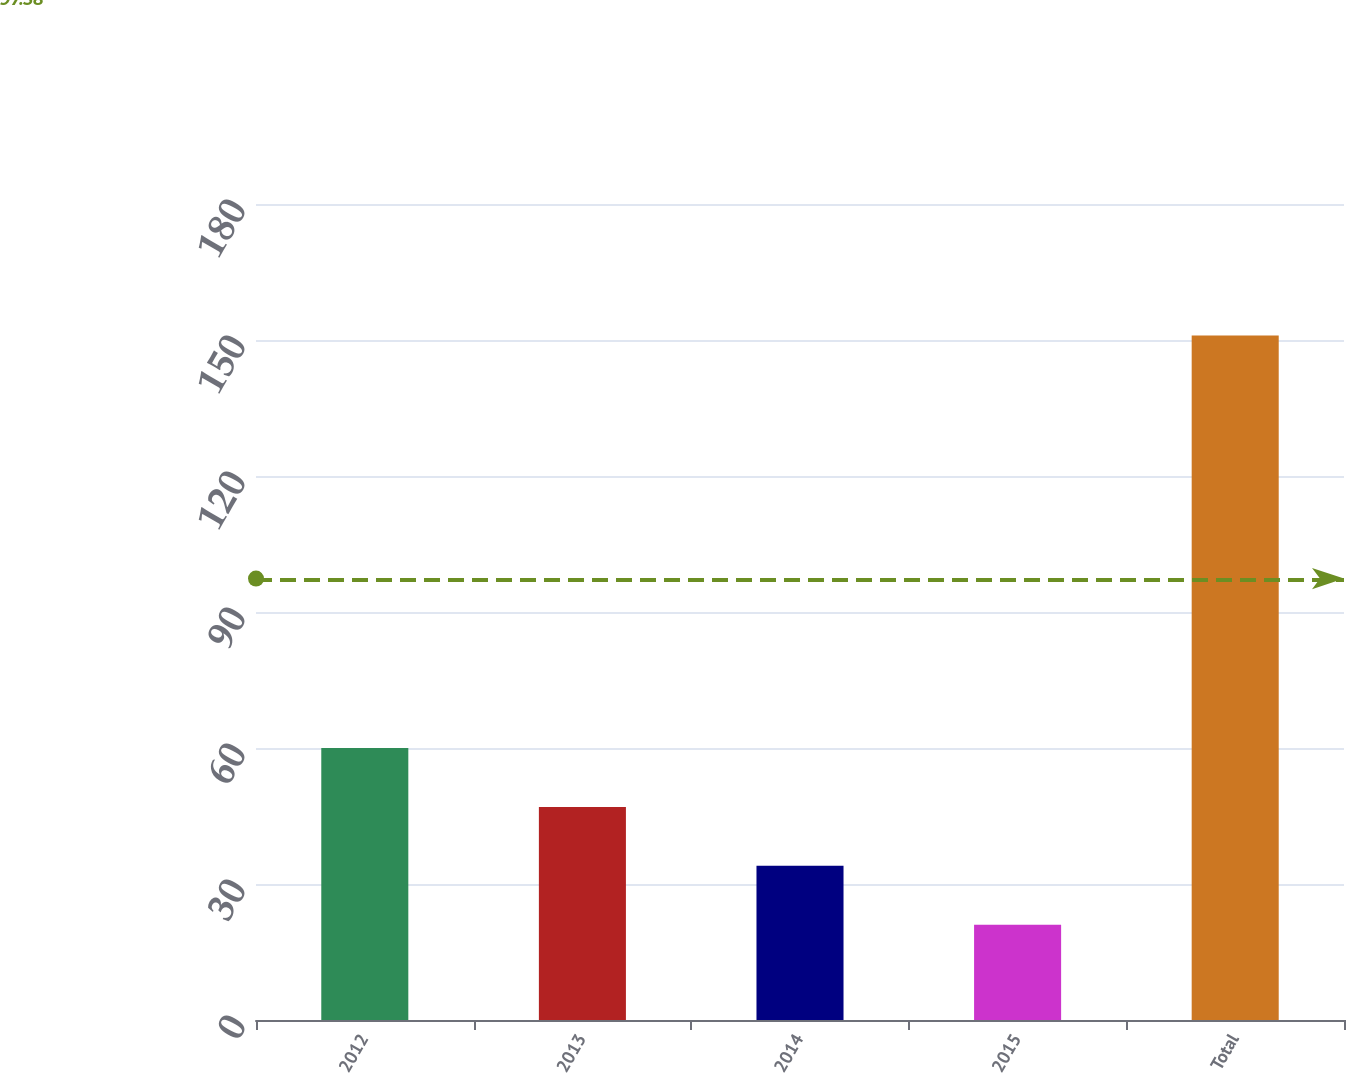Convert chart. <chart><loc_0><loc_0><loc_500><loc_500><bar_chart><fcel>2012<fcel>2013<fcel>2014<fcel>2015<fcel>Total<nl><fcel>60<fcel>47<fcel>34<fcel>21<fcel>151<nl></chart> 